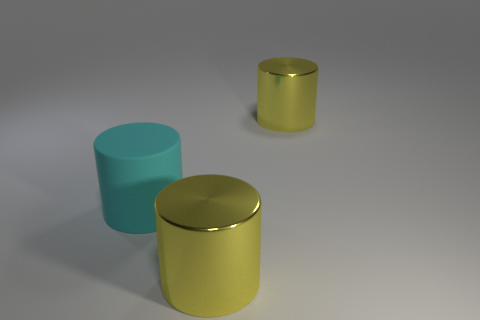What material is the large cyan cylinder that is left of the yellow cylinder behind the large cyan matte object made of?
Offer a very short reply. Rubber. What number of yellow metal things have the same shape as the cyan matte thing?
Ensure brevity in your answer.  2. Is the number of yellow cylinders that are in front of the large cyan rubber object greater than the number of large purple matte blocks?
Offer a terse response. Yes. Are there any large cylinders?
Provide a succinct answer. Yes. How many other shiny cylinders are the same size as the cyan cylinder?
Keep it short and to the point. 2. What is the shape of the cyan object?
Provide a succinct answer. Cylinder. What number of yellow things are big cylinders or large metallic objects?
Your response must be concise. 2. What number of balls are either tiny red metal objects or large yellow objects?
Provide a short and direct response. 0. There is a metal cylinder that is behind the large yellow metal object in front of the matte cylinder; what number of big metal things are in front of it?
Your answer should be compact. 1. Is there anything else that is the same material as the big cyan cylinder?
Provide a short and direct response. No. 